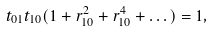<formula> <loc_0><loc_0><loc_500><loc_500>t _ { 0 1 } t _ { 1 0 } ( 1 + r _ { 1 0 } ^ { 2 } + r _ { 1 0 } ^ { 4 } + \dots ) = 1 ,</formula> 